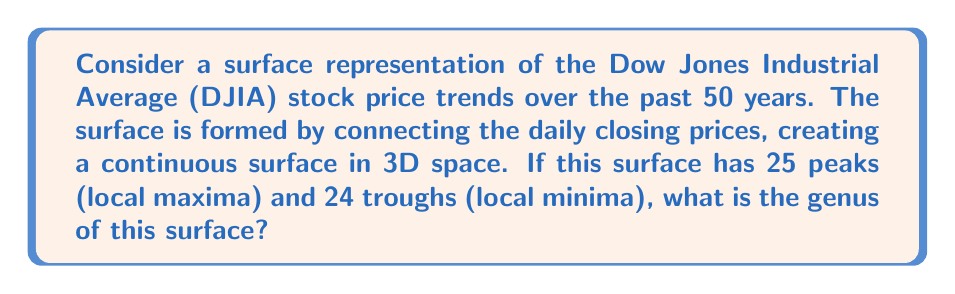Provide a solution to this math problem. To solve this problem, we need to apply concepts from topology, specifically the relationship between the genus of a surface and its Euler characteristic.

1. First, let's recall the Euler-Poincaré formula:
   
   $$ V - E + F = 2 - 2g $$
   
   Where:
   $V$ = number of vertices
   $E$ = number of edges
   $F$ = number of faces
   $g$ = genus of the surface

2. In our case, we have a surface with peaks and troughs. Each peak and trough can be considered a vertex. So:
   
   $V = 25 + 24 = 49$ (25 peaks + 24 troughs)

3. The surface is continuous, formed by connecting daily closing prices. This means we have one face ($F = 1$).

4. To calculate the number of edges, we can use the fact that in a graph where every vertex has degree at least 3 (which is true for our peaks and troughs), we have:
   
   $$ 2E \geq 3V $$
   
   Assuming the minimum case, $2E = 3V$
   $E = \frac{3V}{2} = \frac{3 \times 49}{2} = 73.5$

   Since we need a whole number of edges, we round up: $E = 74$

5. Now we can substitute these values into the Euler-Poincaré formula:

   $$ 49 - 74 + 1 = 2 - 2g $$
   $$ -24 = 2 - 2g $$
   $$ -26 = -2g $$
   $$ g = 13 $$

Therefore, the genus of the surface is 13.
Answer: $$ g = 13 $$ 